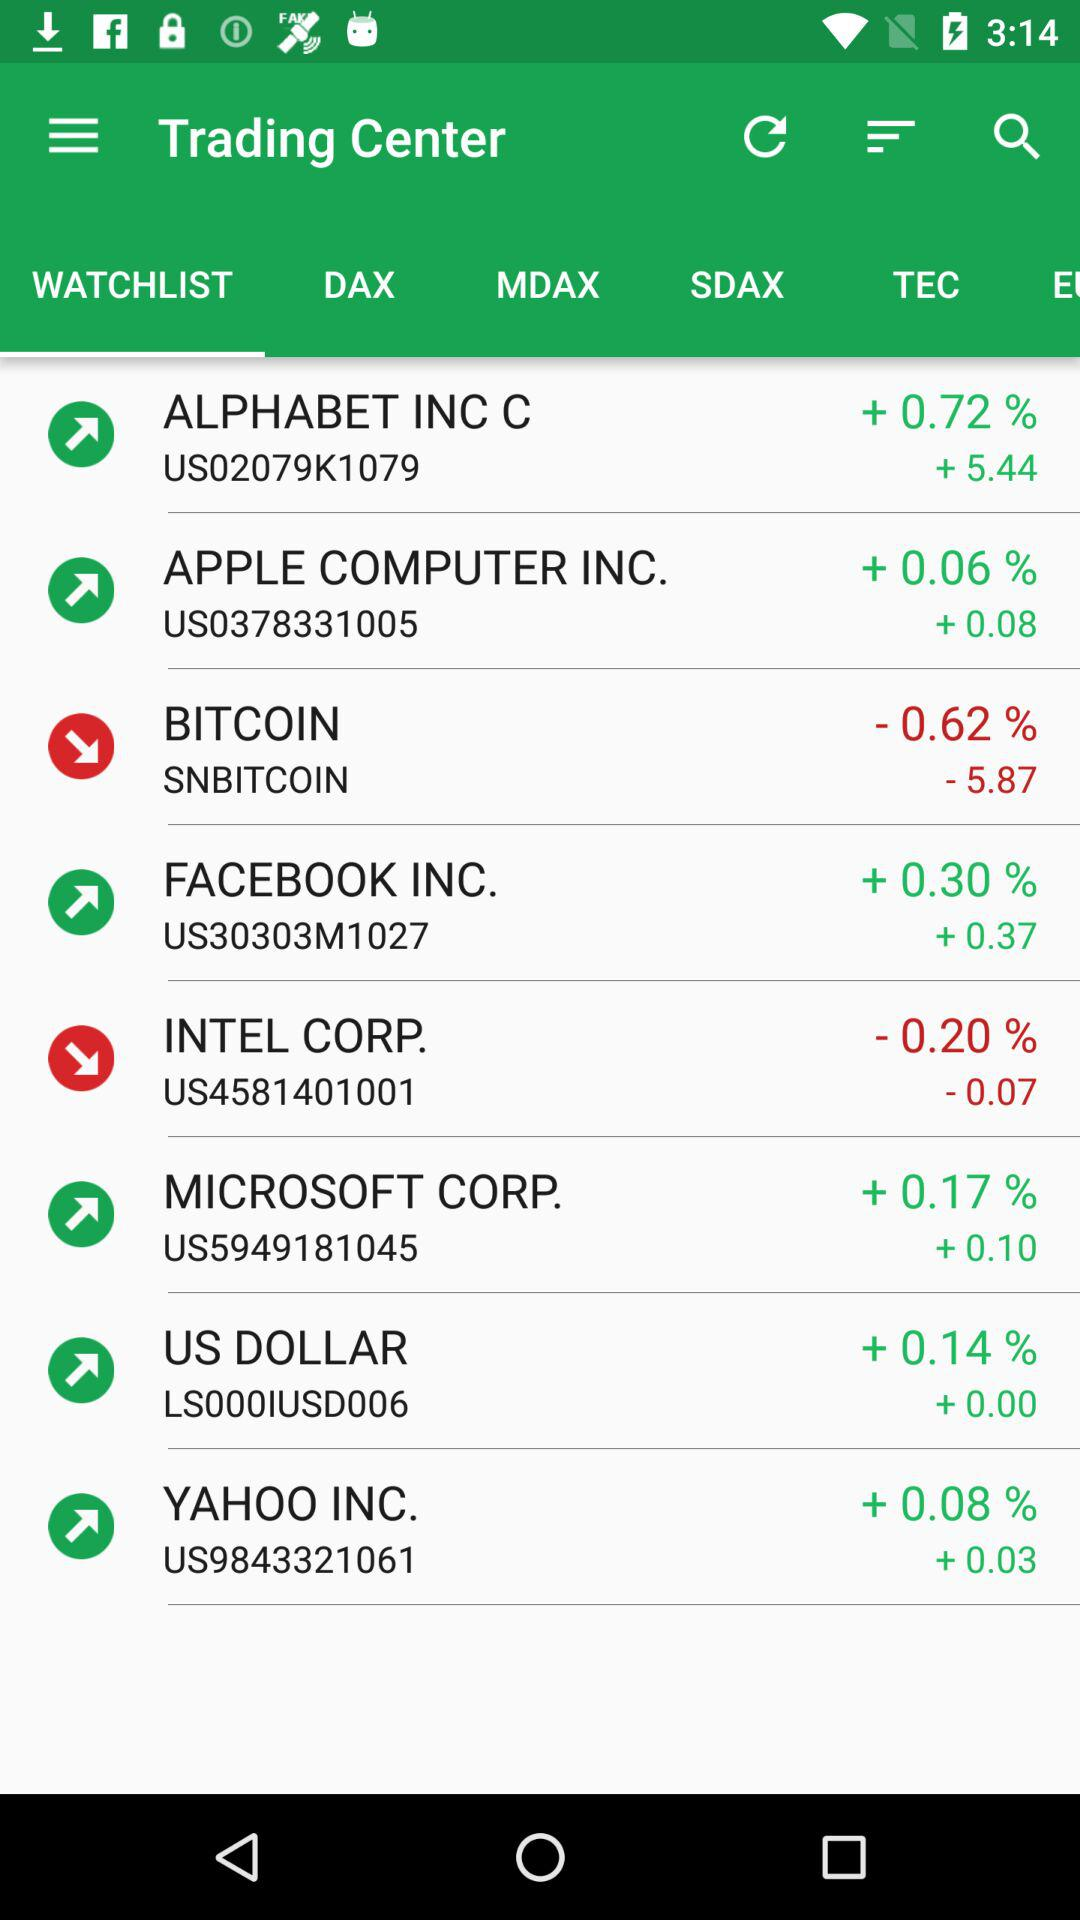What percentage is "BITCOIN" down? Bitcoin is down 0.62%. 